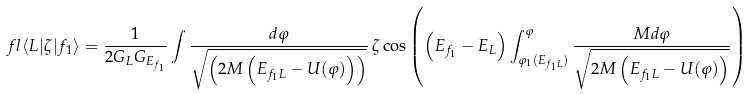Convert formula to latex. <formula><loc_0><loc_0><loc_500><loc_500>\ f l \langle L | \zeta | f _ { 1 } \rangle = \frac { 1 } { 2 G _ { L } G _ { E _ { f _ { 1 } } } } \int \frac { d \varphi } { \sqrt { \left ( 2 M \left ( E _ { f _ { 1 } L } - U ( \varphi ) \right ) \right ) } } \, \zeta \cos \left ( \left ( E _ { f _ { 1 } } - E _ { L } \right ) \int _ { \varphi _ { 1 } ( E _ { f _ { 1 } L } ) } ^ { \varphi } \frac { M d \varphi } { \sqrt { 2 M \left ( E _ { f _ { 1 } L } - U ( \varphi ) \right ) } } \right )</formula> 